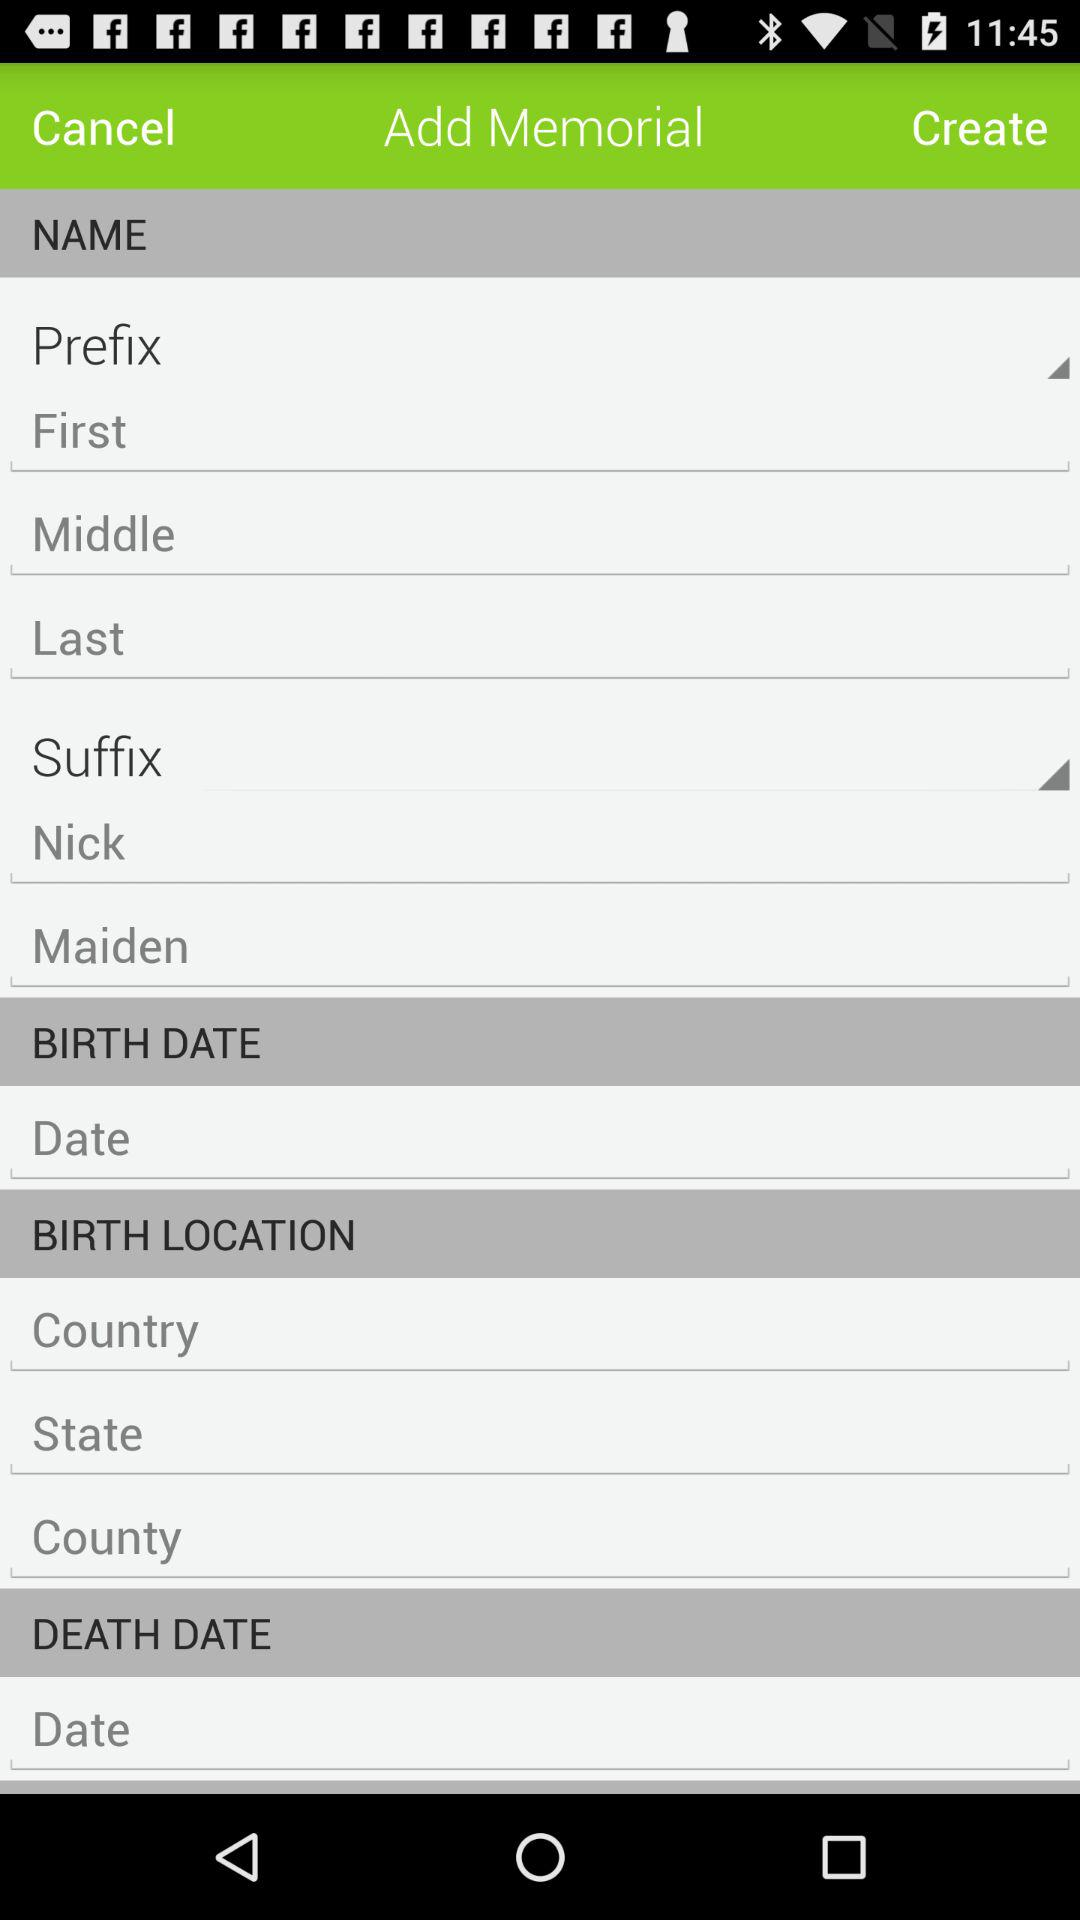How many text fields are there for the location of the person's birth?
Answer the question using a single word or phrase. 3 